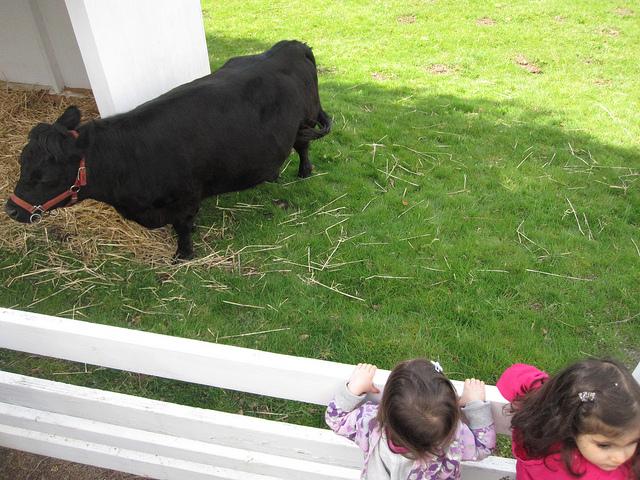How old are the children?
Short answer required. 2. How many child are in view?
Write a very short answer. 2. How many cows are there?
Keep it brief. 1. 